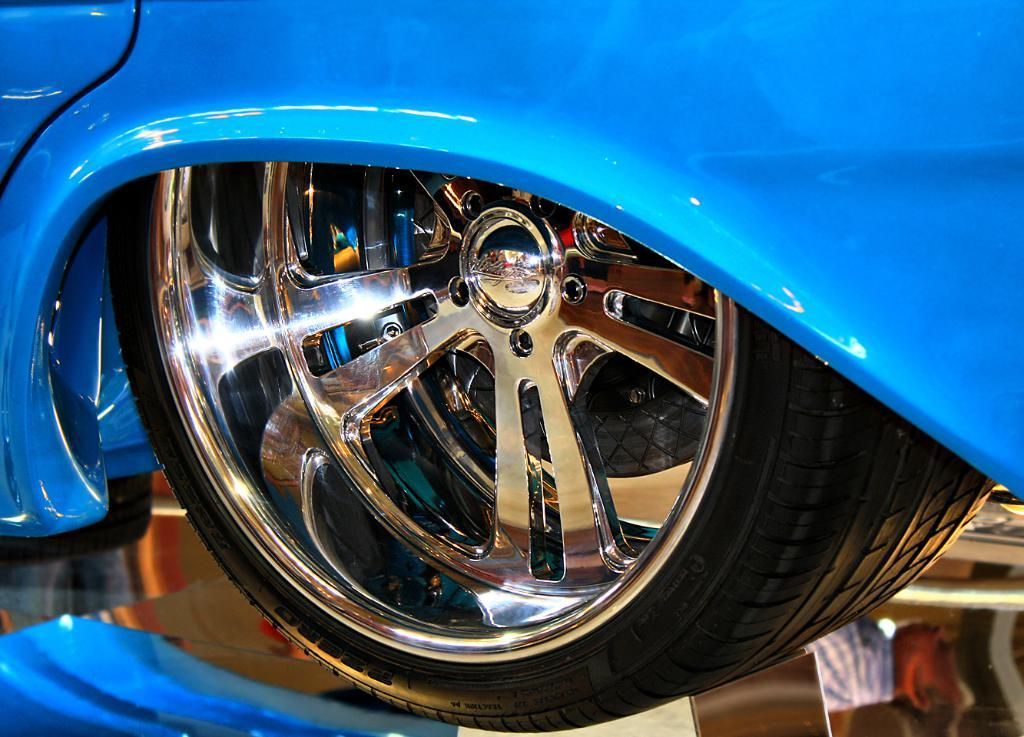What object related to a vehicle can be seen in the image? There is a tyre of a vehicle in the image. What other object is present in the image? There is a glass in the image. What can be observed in the glass? The glass contains reflections of two persons. Can you see any snails swimming in the ocean in the image? There is no ocean or snails present in the image; it features a tyre of a vehicle and a glass with reflections of two persons. 